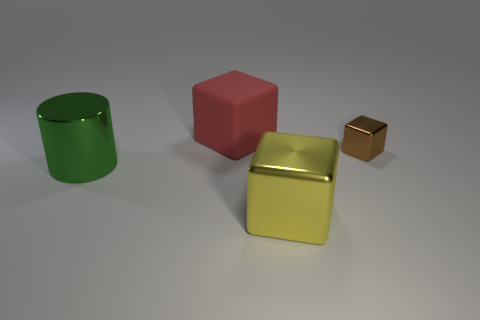Add 2 small metal cubes. How many objects exist? 6 Subtract all cylinders. How many objects are left? 3 Subtract 0 purple cylinders. How many objects are left? 4 Subtract all purple balls. Subtract all green metal things. How many objects are left? 3 Add 4 large green metallic cylinders. How many large green metallic cylinders are left? 5 Add 4 large green cylinders. How many large green cylinders exist? 5 